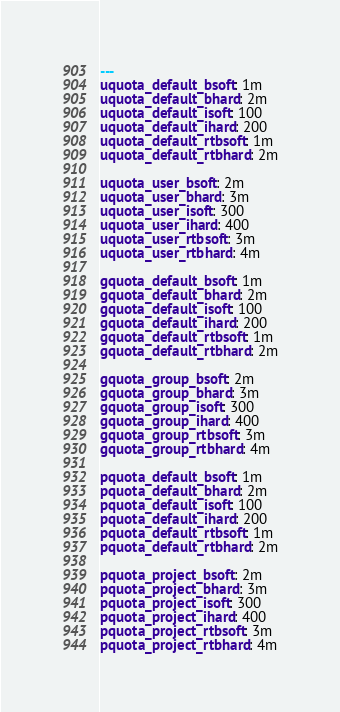<code> <loc_0><loc_0><loc_500><loc_500><_YAML_>---
uquota_default_bsoft: 1m
uquota_default_bhard: 2m
uquota_default_isoft: 100
uquota_default_ihard: 200
uquota_default_rtbsoft: 1m
uquota_default_rtbhard: 2m

uquota_user_bsoft: 2m
uquota_user_bhard: 3m
uquota_user_isoft: 300
uquota_user_ihard: 400
uquota_user_rtbsoft: 3m
uquota_user_rtbhard: 4m

gquota_default_bsoft: 1m
gquota_default_bhard: 2m
gquota_default_isoft: 100
gquota_default_ihard: 200
gquota_default_rtbsoft: 1m
gquota_default_rtbhard: 2m

gquota_group_bsoft: 2m
gquota_group_bhard: 3m
gquota_group_isoft: 300
gquota_group_ihard: 400
gquota_group_rtbsoft: 3m
gquota_group_rtbhard: 4m

pquota_default_bsoft: 1m
pquota_default_bhard: 2m
pquota_default_isoft: 100
pquota_default_ihard: 200
pquota_default_rtbsoft: 1m
pquota_default_rtbhard: 2m

pquota_project_bsoft: 2m
pquota_project_bhard: 3m
pquota_project_isoft: 300
pquota_project_ihard: 400
pquota_project_rtbsoft: 3m
pquota_project_rtbhard: 4m
</code> 